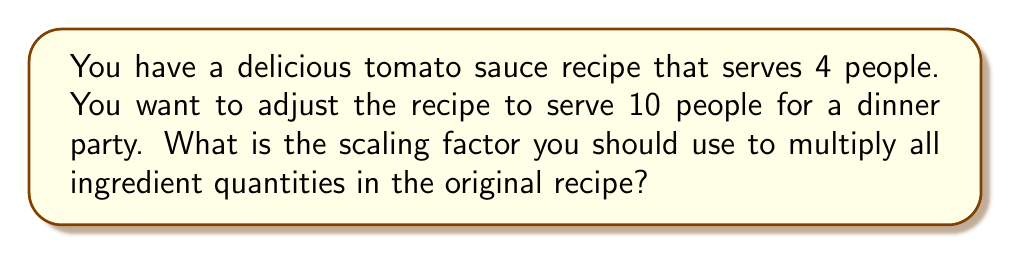Help me with this question. Let's approach this step-by-step:

1) First, we need to understand what a scaling factor is. It's a number we multiply all quantities by to adjust the recipe.

2) We can express this as a ratio:

   $$ \text{Scaling Factor} = \frac{\text{New Number of Servings}}{\text{Original Number of Servings}} $$

3) In this case:
   - Original number of servings = 4
   - New number of servings = 10

4) Let's plug these numbers into our formula:

   $$ \text{Scaling Factor} = \frac{10}{4} $$

5) Now, we simply need to perform this division:

   $$ \text{Scaling Factor} = \frac{10}{4} = 2.5 $$

6) This means you need to multiply all ingredient quantities in the original recipe by 2.5 to make enough sauce for 10 people.

For example, if the original recipe calls for 2 cups of tomatoes, you would use:
$$ 2 \text{ cups} \times 2.5 = 5 \text{ cups} $$
Answer: 2.5 